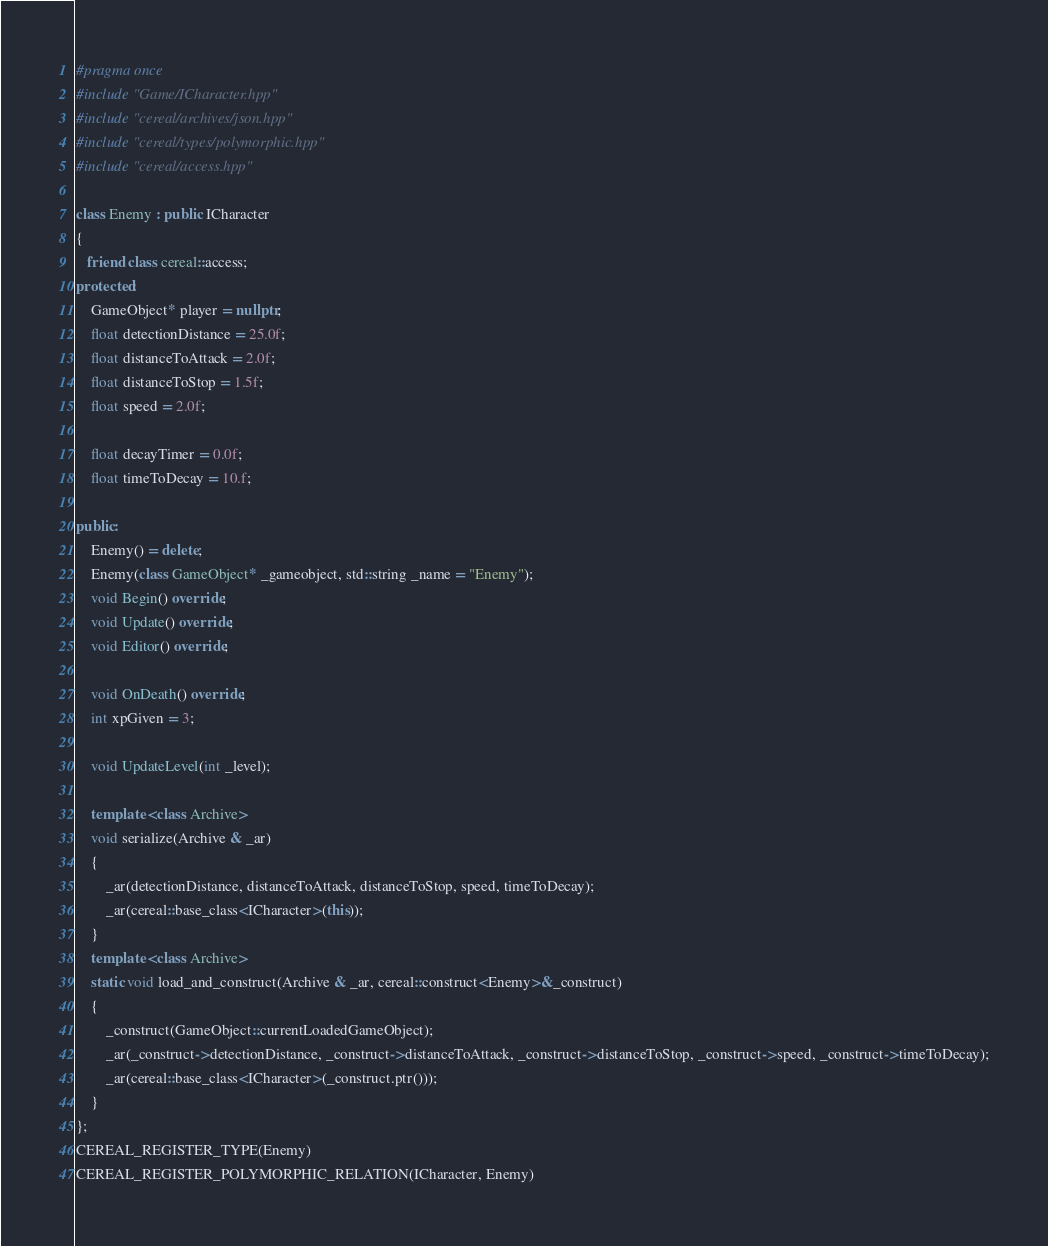<code> <loc_0><loc_0><loc_500><loc_500><_C++_>#pragma once
#include "Game/ICharacter.hpp"
#include "cereal/archives/json.hpp"
#include "cereal/types/polymorphic.hpp"
#include "cereal/access.hpp"

class Enemy : public ICharacter
{
   friend class cereal::access;
protected:
    GameObject* player = nullptr;
    float detectionDistance = 25.0f;
    float distanceToAttack = 2.0f;
    float distanceToStop = 1.5f;
    float speed = 2.0f;

    float decayTimer = 0.0f;
    float timeToDecay = 10.f;

public:
    Enemy() = delete;
    Enemy(class GameObject* _gameobject, std::string _name = "Enemy");
    void Begin() override;
    void Update() override;
    void Editor() override;
    
    void OnDeath() override;
    int xpGiven = 3;

    void UpdateLevel(int _level);

    template <class Archive>
    void serialize(Archive & _ar)
    {
        _ar(detectionDistance, distanceToAttack, distanceToStop, speed, timeToDecay);
        _ar(cereal::base_class<ICharacter>(this));
    }
    template <class Archive>
    static void load_and_construct(Archive & _ar, cereal::construct<Enemy>&_construct)
    {
        _construct(GameObject::currentLoadedGameObject);
        _ar(_construct->detectionDistance, _construct->distanceToAttack, _construct->distanceToStop, _construct->speed, _construct->timeToDecay);
        _ar(cereal::base_class<ICharacter>(_construct.ptr()));
    }
};
CEREAL_REGISTER_TYPE(Enemy)
CEREAL_REGISTER_POLYMORPHIC_RELATION(ICharacter, Enemy)</code> 